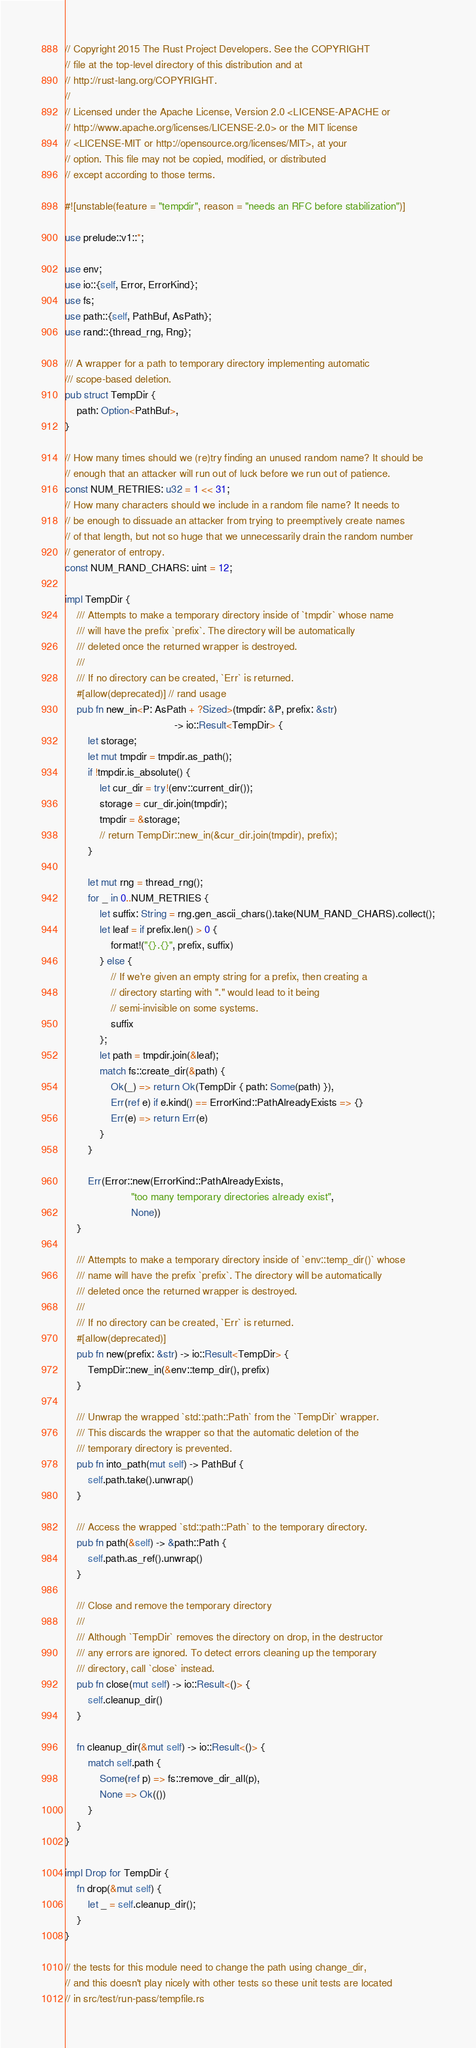Convert code to text. <code><loc_0><loc_0><loc_500><loc_500><_Rust_>// Copyright 2015 The Rust Project Developers. See the COPYRIGHT
// file at the top-level directory of this distribution and at
// http://rust-lang.org/COPYRIGHT.
//
// Licensed under the Apache License, Version 2.0 <LICENSE-APACHE or
// http://www.apache.org/licenses/LICENSE-2.0> or the MIT license
// <LICENSE-MIT or http://opensource.org/licenses/MIT>, at your
// option. This file may not be copied, modified, or distributed
// except according to those terms.

#![unstable(feature = "tempdir", reason = "needs an RFC before stabilization")]

use prelude::v1::*;

use env;
use io::{self, Error, ErrorKind};
use fs;
use path::{self, PathBuf, AsPath};
use rand::{thread_rng, Rng};

/// A wrapper for a path to temporary directory implementing automatic
/// scope-based deletion.
pub struct TempDir {
    path: Option<PathBuf>,
}

// How many times should we (re)try finding an unused random name? It should be
// enough that an attacker will run out of luck before we run out of patience.
const NUM_RETRIES: u32 = 1 << 31;
// How many characters should we include in a random file name? It needs to
// be enough to dissuade an attacker from trying to preemptively create names
// of that length, but not so huge that we unnecessarily drain the random number
// generator of entropy.
const NUM_RAND_CHARS: uint = 12;

impl TempDir {
    /// Attempts to make a temporary directory inside of `tmpdir` whose name
    /// will have the prefix `prefix`. The directory will be automatically
    /// deleted once the returned wrapper is destroyed.
    ///
    /// If no directory can be created, `Err` is returned.
    #[allow(deprecated)] // rand usage
    pub fn new_in<P: AsPath + ?Sized>(tmpdir: &P, prefix: &str)
                                      -> io::Result<TempDir> {
        let storage;
        let mut tmpdir = tmpdir.as_path();
        if !tmpdir.is_absolute() {
            let cur_dir = try!(env::current_dir());
            storage = cur_dir.join(tmpdir);
            tmpdir = &storage;
            // return TempDir::new_in(&cur_dir.join(tmpdir), prefix);
        }

        let mut rng = thread_rng();
        for _ in 0..NUM_RETRIES {
            let suffix: String = rng.gen_ascii_chars().take(NUM_RAND_CHARS).collect();
            let leaf = if prefix.len() > 0 {
                format!("{}.{}", prefix, suffix)
            } else {
                // If we're given an empty string for a prefix, then creating a
                // directory starting with "." would lead to it being
                // semi-invisible on some systems.
                suffix
            };
            let path = tmpdir.join(&leaf);
            match fs::create_dir(&path) {
                Ok(_) => return Ok(TempDir { path: Some(path) }),
                Err(ref e) if e.kind() == ErrorKind::PathAlreadyExists => {}
                Err(e) => return Err(e)
            }
        }

        Err(Error::new(ErrorKind::PathAlreadyExists,
                       "too many temporary directories already exist",
                       None))
    }

    /// Attempts to make a temporary directory inside of `env::temp_dir()` whose
    /// name will have the prefix `prefix`. The directory will be automatically
    /// deleted once the returned wrapper is destroyed.
    ///
    /// If no directory can be created, `Err` is returned.
    #[allow(deprecated)]
    pub fn new(prefix: &str) -> io::Result<TempDir> {
        TempDir::new_in(&env::temp_dir(), prefix)
    }

    /// Unwrap the wrapped `std::path::Path` from the `TempDir` wrapper.
    /// This discards the wrapper so that the automatic deletion of the
    /// temporary directory is prevented.
    pub fn into_path(mut self) -> PathBuf {
        self.path.take().unwrap()
    }

    /// Access the wrapped `std::path::Path` to the temporary directory.
    pub fn path(&self) -> &path::Path {
        self.path.as_ref().unwrap()
    }

    /// Close and remove the temporary directory
    ///
    /// Although `TempDir` removes the directory on drop, in the destructor
    /// any errors are ignored. To detect errors cleaning up the temporary
    /// directory, call `close` instead.
    pub fn close(mut self) -> io::Result<()> {
        self.cleanup_dir()
    }

    fn cleanup_dir(&mut self) -> io::Result<()> {
        match self.path {
            Some(ref p) => fs::remove_dir_all(p),
            None => Ok(())
        }
    }
}

impl Drop for TempDir {
    fn drop(&mut self) {
        let _ = self.cleanup_dir();
    }
}

// the tests for this module need to change the path using change_dir,
// and this doesn't play nicely with other tests so these unit tests are located
// in src/test/run-pass/tempfile.rs
</code> 